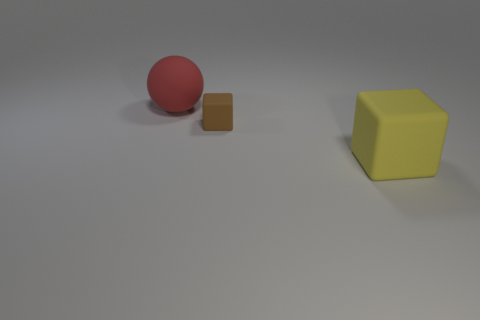How many other objects are the same size as the matte sphere?
Ensure brevity in your answer.  1. Does the rubber object in front of the tiny brown object have the same shape as the brown matte thing?
Your answer should be very brief. Yes. Is the number of cubes to the left of the yellow rubber block greater than the number of small gray rubber cylinders?
Ensure brevity in your answer.  Yes. What is the thing that is on the left side of the yellow object and in front of the red thing made of?
Offer a very short reply. Rubber. Is there any other thing that is the same shape as the red matte object?
Provide a succinct answer. No. What number of large objects are behind the yellow block and in front of the tiny matte thing?
Provide a succinct answer. 0. Are there the same number of small matte objects that are to the left of the matte sphere and red shiny things?
Provide a short and direct response. Yes. How many large red objects are the same shape as the tiny object?
Provide a short and direct response. 0. Does the big red matte object have the same shape as the yellow rubber object?
Your answer should be compact. No. How many objects are objects left of the brown cube or big matte balls?
Offer a terse response. 1. 